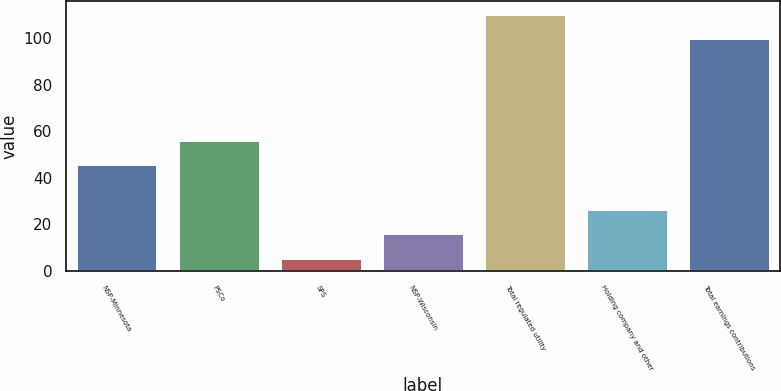Convert chart. <chart><loc_0><loc_0><loc_500><loc_500><bar_chart><fcel>NSP-Minnesota<fcel>PSCo<fcel>SPS<fcel>NSP-Wisconsin<fcel>Total regulated utility<fcel>Holding company and other<fcel>Total earnings contributions<nl><fcel>45.9<fcel>56.24<fcel>5.7<fcel>16.04<fcel>110.34<fcel>26.38<fcel>100<nl></chart> 